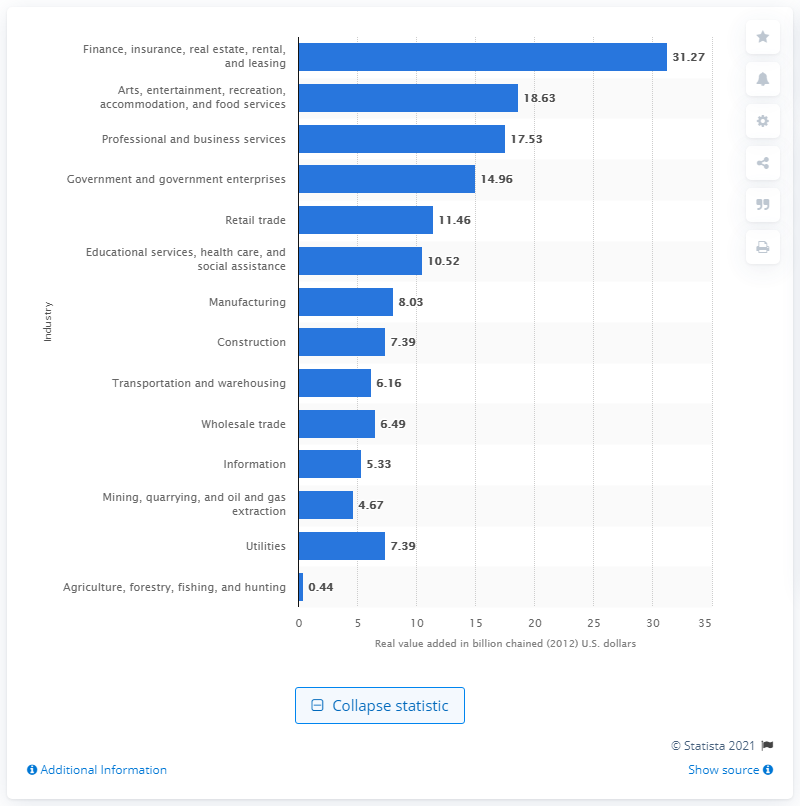Highlight a few significant elements in this photo. The finance, insurance, real estate, rental, and leasing industry contributed 31.27% to the gross domestic product of Nevada in 2012. 